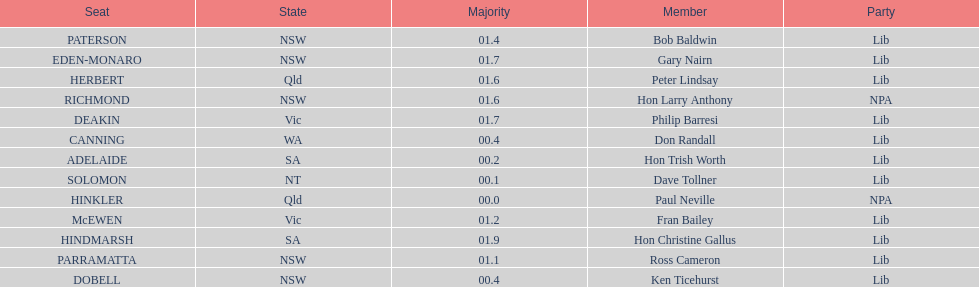What is the name of the last seat? HINDMARSH. 